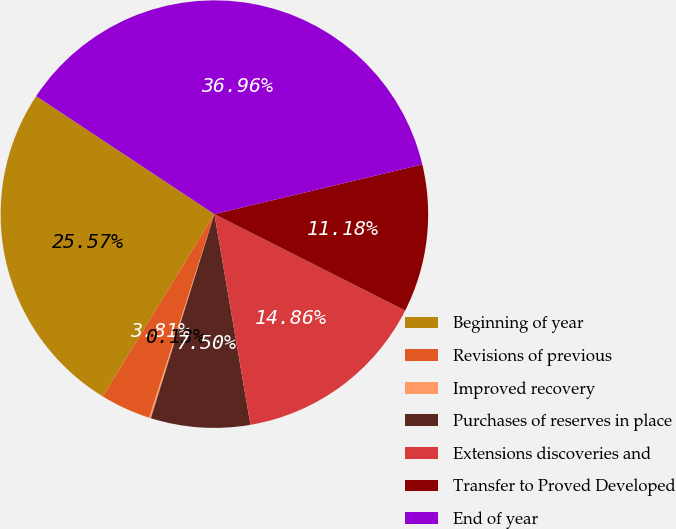Convert chart to OTSL. <chart><loc_0><loc_0><loc_500><loc_500><pie_chart><fcel>Beginning of year<fcel>Revisions of previous<fcel>Improved recovery<fcel>Purchases of reserves in place<fcel>Extensions discoveries and<fcel>Transfer to Proved Developed<fcel>End of year<nl><fcel>25.57%<fcel>3.81%<fcel>0.13%<fcel>7.5%<fcel>14.86%<fcel>11.18%<fcel>36.96%<nl></chart> 